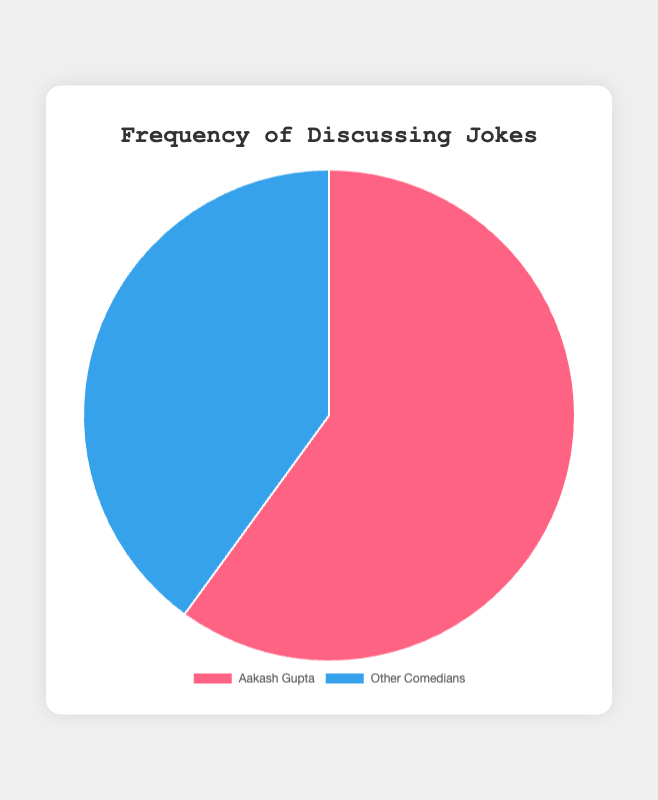Which category has the higher percentage of joke discussions? The pie chart shows two categories: Aakash Gupta and Other Comedians, with percentages 60% and 40%, respectively. The higher value is 60%.
Answer: Aakash Gupta What is the difference in percentage between discussions about Aakash Gupta's jokes and other comedians' jokes? The percentage for Aakash Gupta is 60% and for Other Comedians is 40%. The difference is 60% - 40% = 20%.
Answer: 20% Which color in the pie chart represents discussions about other comedians' jokes? The chart legend shows two colors. Blue represents Other Comedians.
Answer: Blue What percentage of joke discussions pertain to Aakash Gupta? According to the pie chart, the segment representing Aakash Gupta has a value of 60%.
Answer: 60% Are discussions about Aakash Gupta's jokes more frequent than discussions about other comedians' jokes? The pie chart shows that Aakash Gupta occupies 60% of joke discussions, whereas Other Comedians occupy 40%. Therefore, Aakash Gupta's jokes are more frequently discussed.
Answer: Yes If the total number of joke discussions is 100, how many of these discussions are about Aakash Gupta's jokes? If Aakash Gupta's joke discussions account for 60%, then 60% of 100 discussions is calculated as (60/100) * 100 = 60.
Answer: 60 What is the sum of the percentages for both categories in the pie chart? The pie chart has two segments with percentages 60% and 40%. Adding them, 60% + 40% = 100%.
Answer: 100% If you were to combine both categories into one, what percentage would that represent? Since the pie chart represents the whole dataset as 100%, combining both categories, which are 60% and 40%, will remain 100%.
Answer: 100% What is the ratio of discussions about Aakash Gupta's jokes to discussions about other comedians' jokes? The percentage for Aakash Gupta is 60% and for Other Comedians is 40%. The ratio is 60:40, which can be simplified to 3:2.
Answer: 3:2 